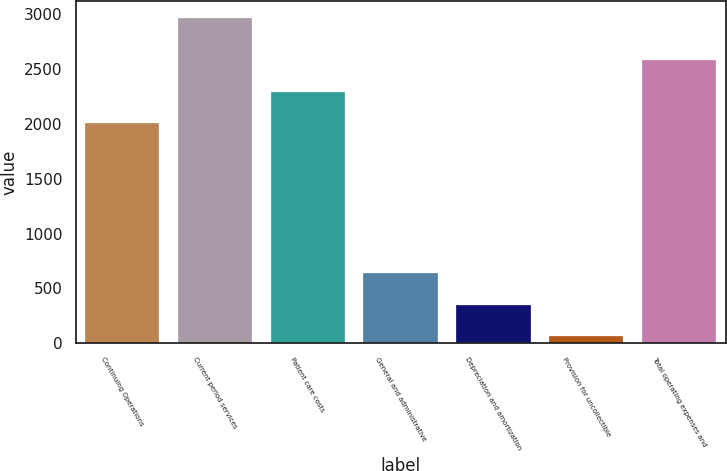<chart> <loc_0><loc_0><loc_500><loc_500><bar_chart><fcel>Continuing Operations<fcel>Current period services<fcel>Patient care costs<fcel>General and administrative<fcel>Depreciation and amortization<fcel>Provision for uncollectible<fcel>Total operating expenses and<nl><fcel>2005<fcel>2970<fcel>2295.8<fcel>643.6<fcel>352.8<fcel>62<fcel>2586.6<nl></chart> 